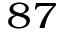<formula> <loc_0><loc_0><loc_500><loc_500>^ { 8 7 }</formula> 